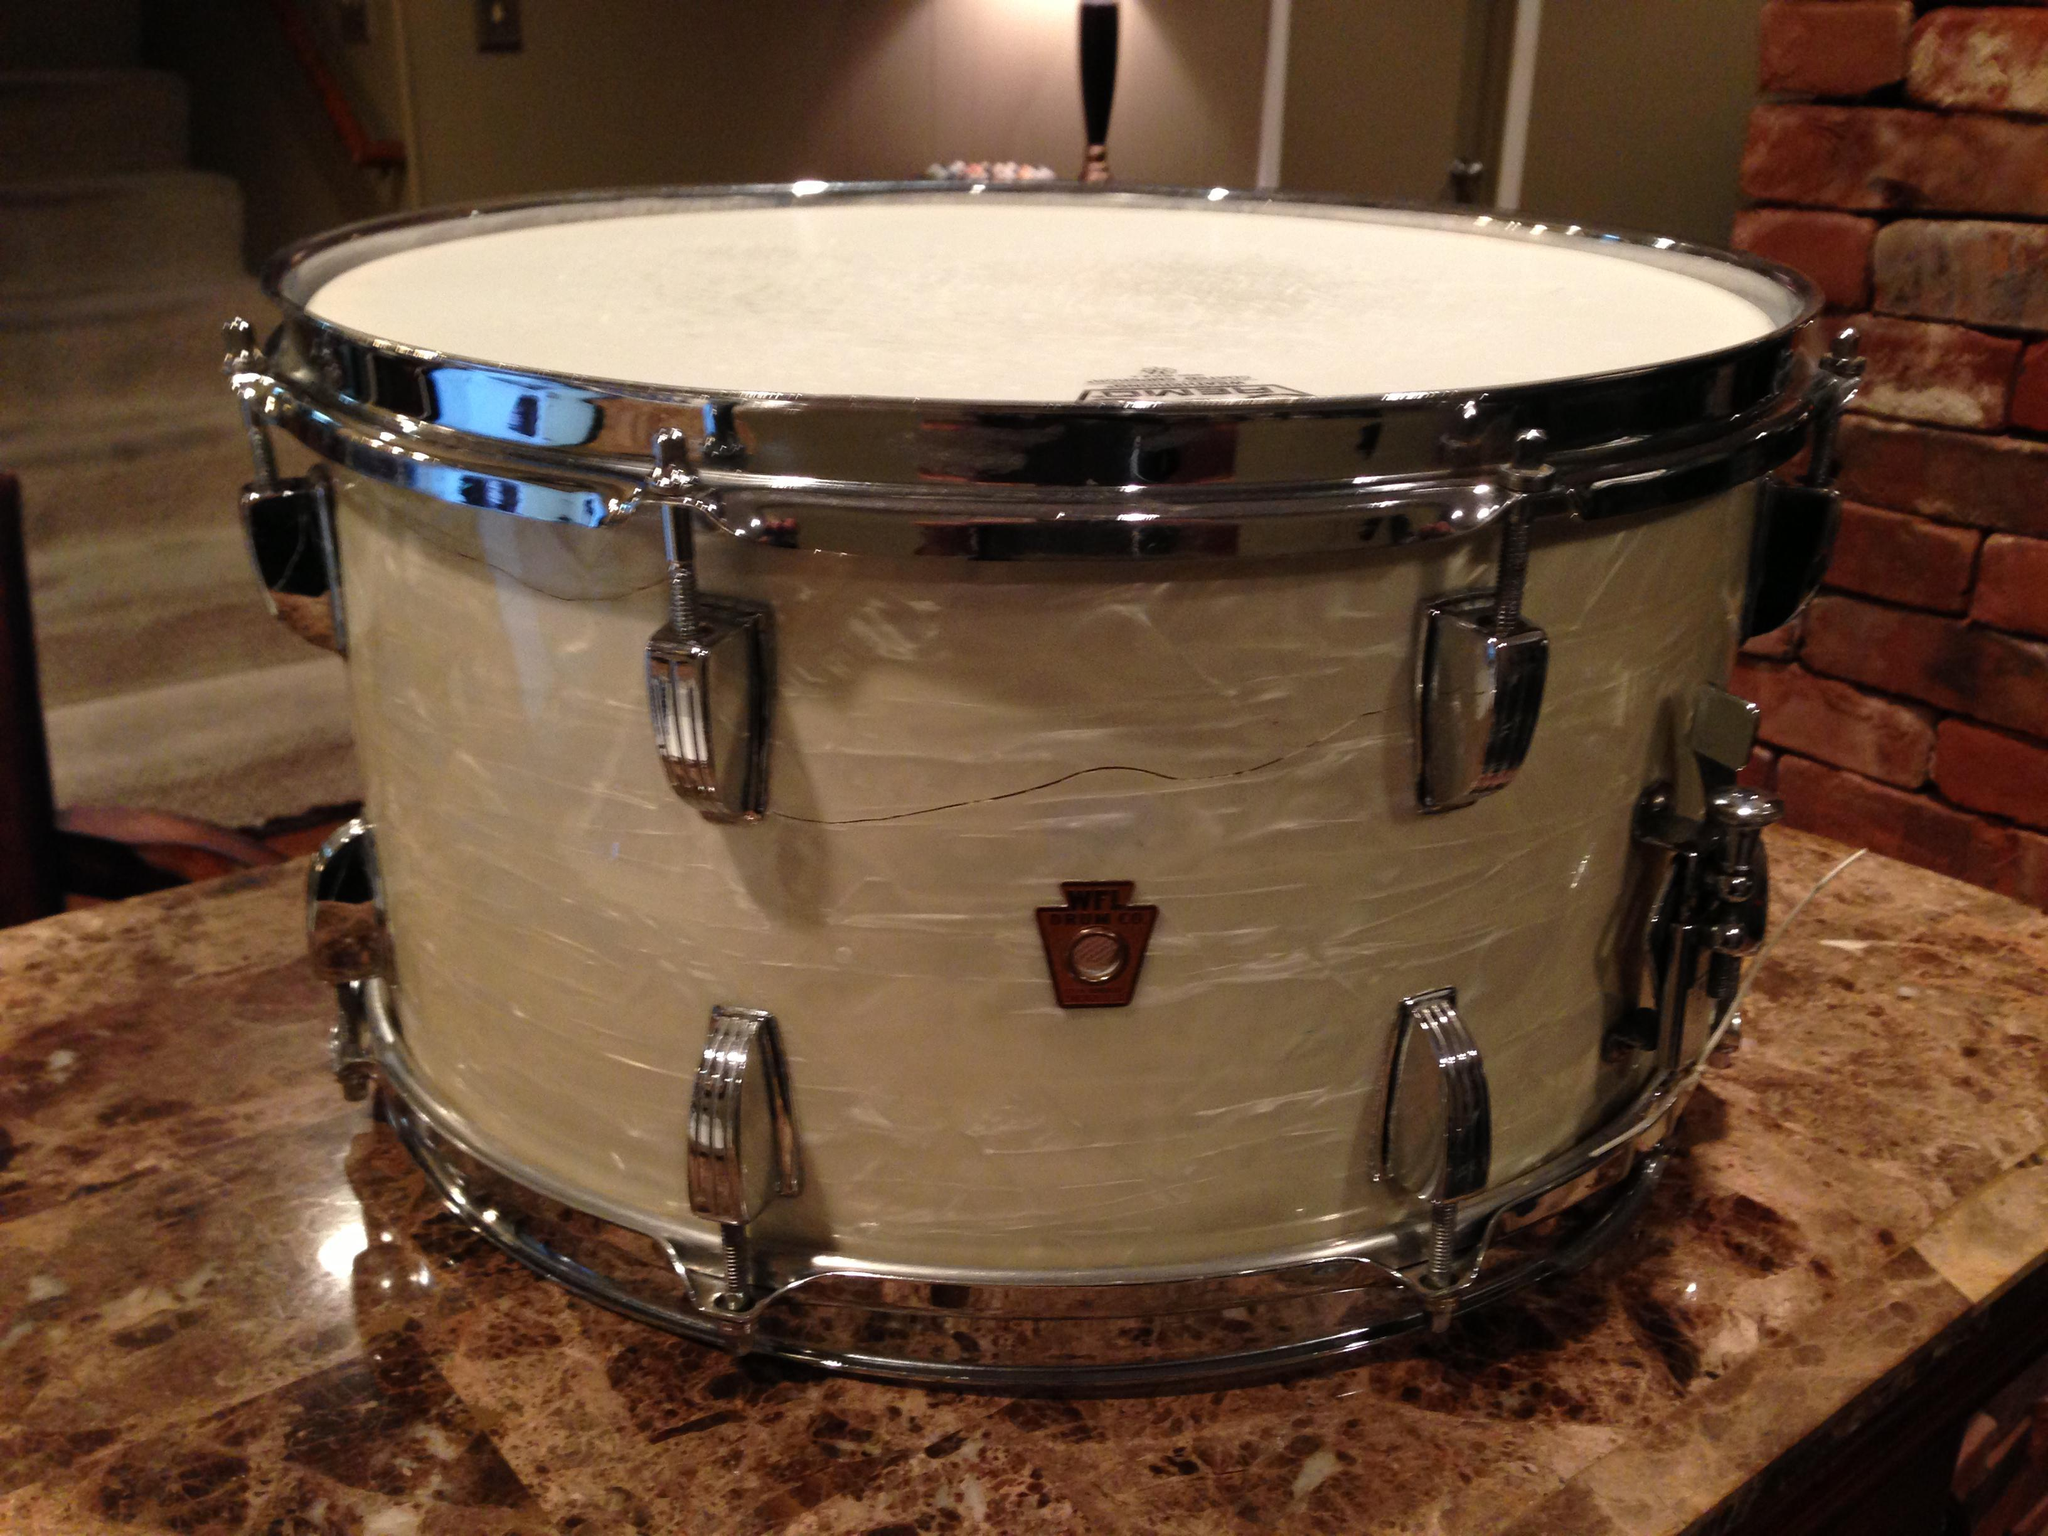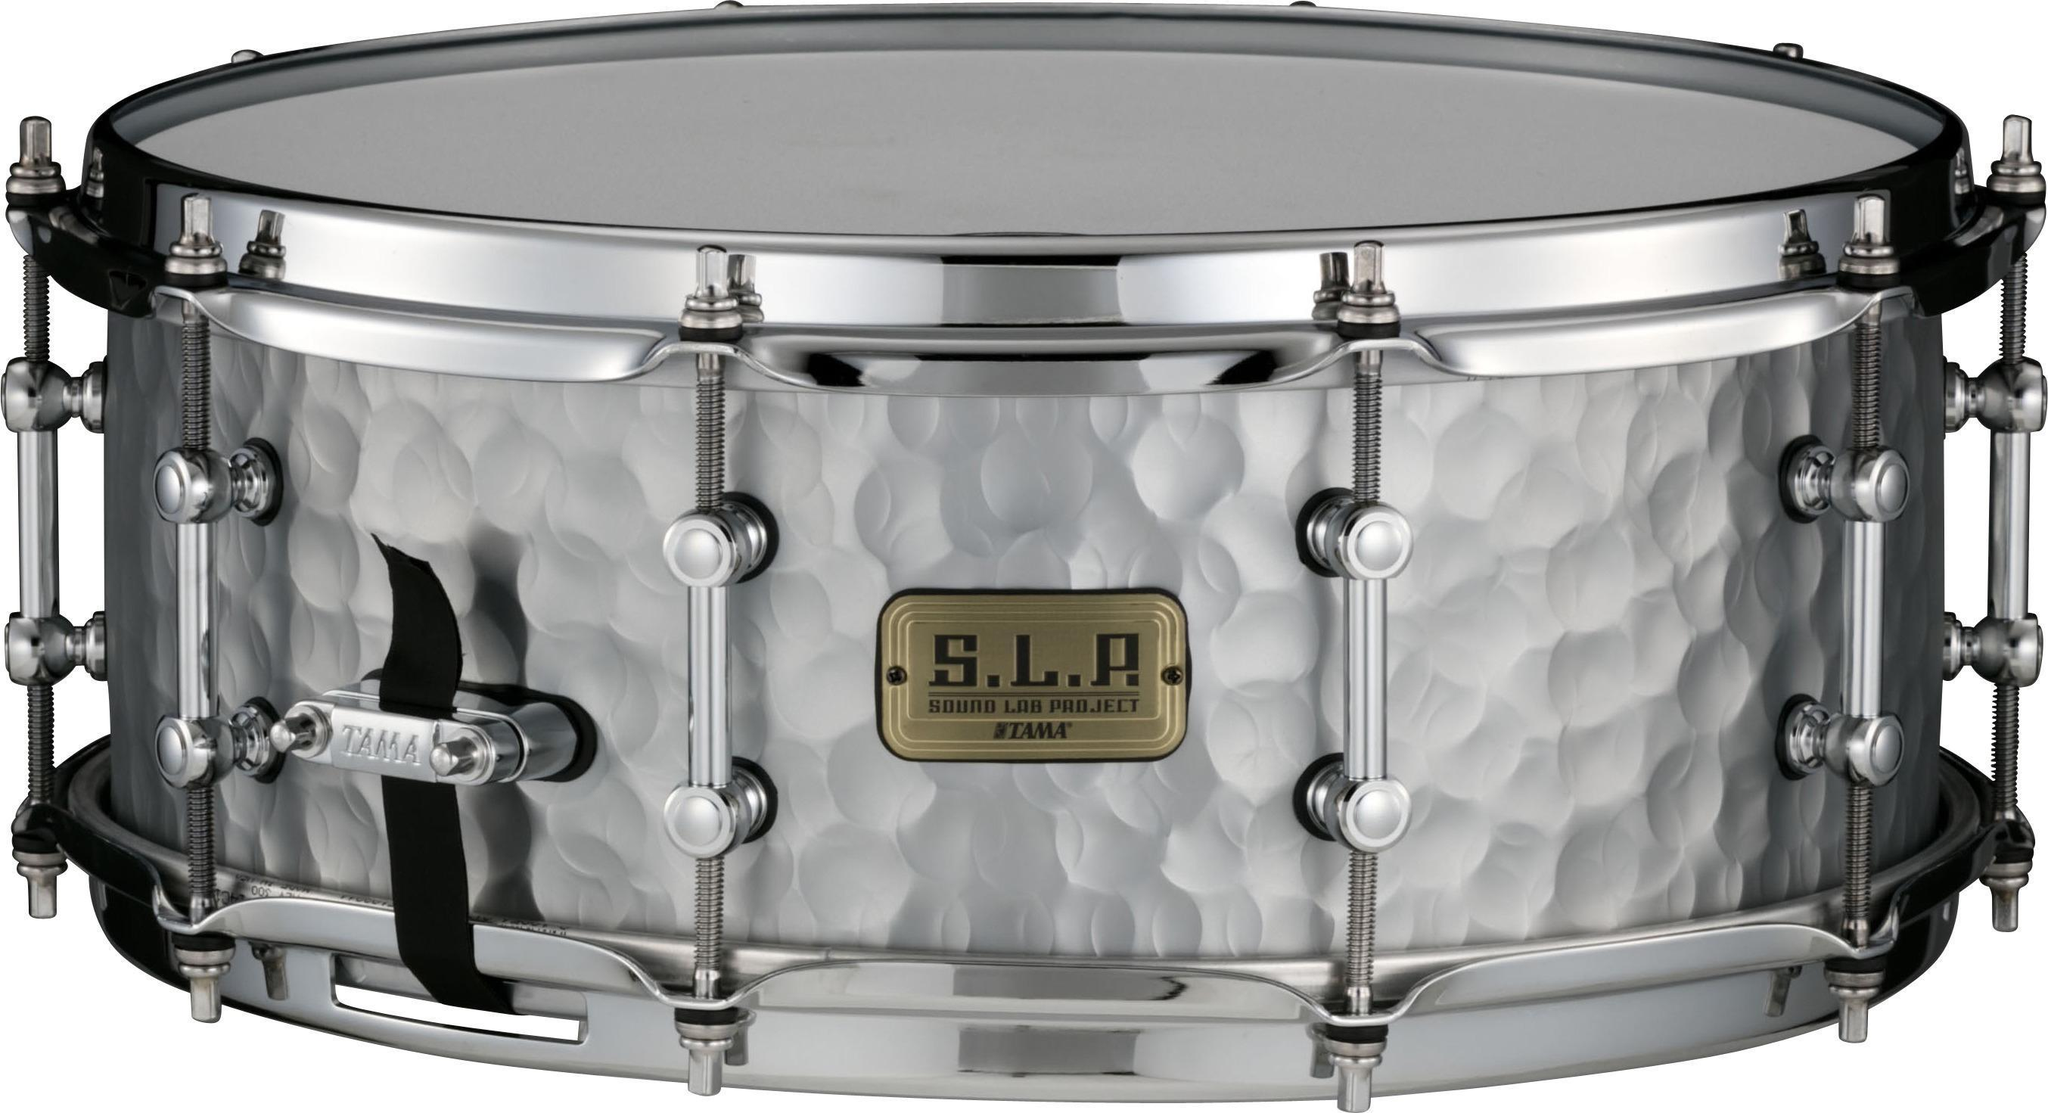The first image is the image on the left, the second image is the image on the right. Analyze the images presented: Is the assertion "The drum on the left is white." valid? Answer yes or no. No. The first image is the image on the left, the second image is the image on the right. Given the left and right images, does the statement "All drums are the same height and are displayed at the same angle, and at least one drum has an oval label centered on the side facing the camera." hold true? Answer yes or no. No. 